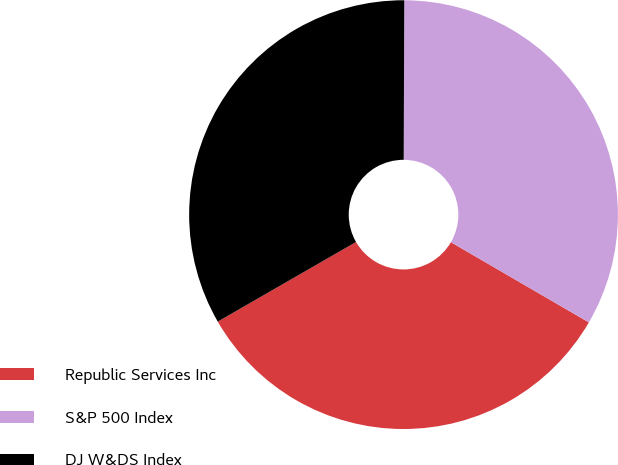Convert chart. <chart><loc_0><loc_0><loc_500><loc_500><pie_chart><fcel>Republic Services Inc<fcel>S&P 500 Index<fcel>DJ W&DS Index<nl><fcel>33.3%<fcel>33.33%<fcel>33.37%<nl></chart> 